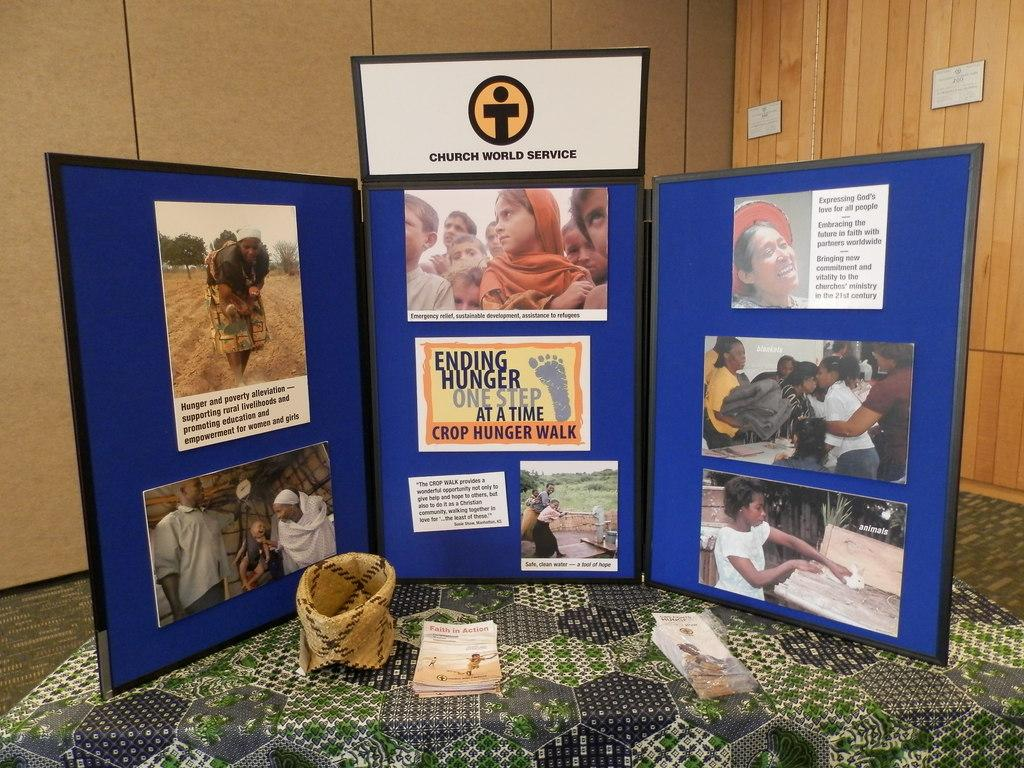What is the color of the frame that contains photos in the image? The frame is blue in color. What type of material is the frame made of? The information provided does not specify the material of the frame. What can be seen on the wall in the image? There is a wooden panel wall visible in the image. Can you describe the texture of the wall? The texture of the wall is not mentioned in the provided facts. What type of wool is being used for reading in the image? There is no wool or reading activity present in the image. 